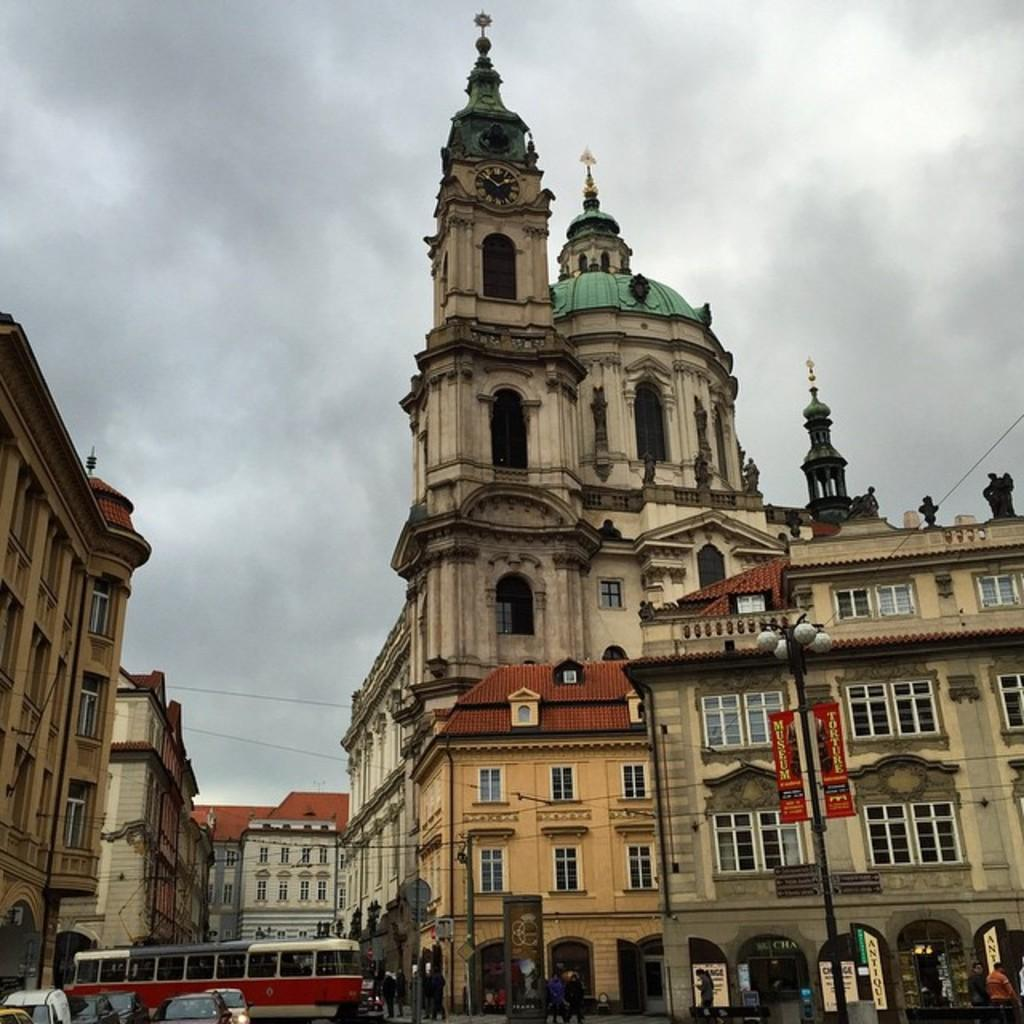What is happening on the road in the image? There are vehicles on a road in the image. What are people doing in the image? People are walking on a footpath in the image. What structures can be seen in the image? There are poles and buildings in the image. What can be seen above the structures in the image? The sky is visible in the image. Can you hear a whistle in the image? There is no mention of a whistle in the image, so it cannot be heard. Are there any mountains visible in the image? There is no mention of mountains in the image, so they are not visible. 